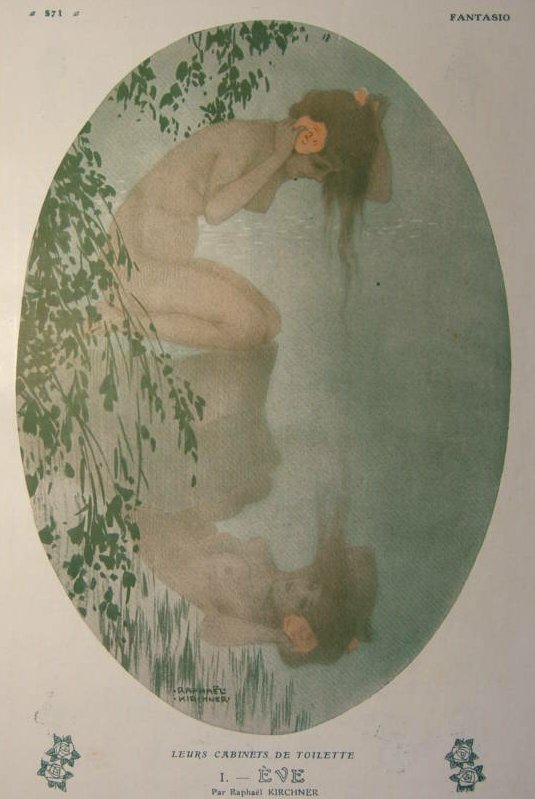Describe a realistic scenario that this image might depict. A woman finding a moment of solitude by a forest pond. After a long, weary day, she takes a quiet walk into the woods, seeking refuge from life's chaos. Here, she kneels by the water, allowing the cool breeze and the gentle sound of the flowing stream to wash over her. She finds a single pink flower on the water's edge and holds it close, feeling a serene connection to this quiet, natural space. 